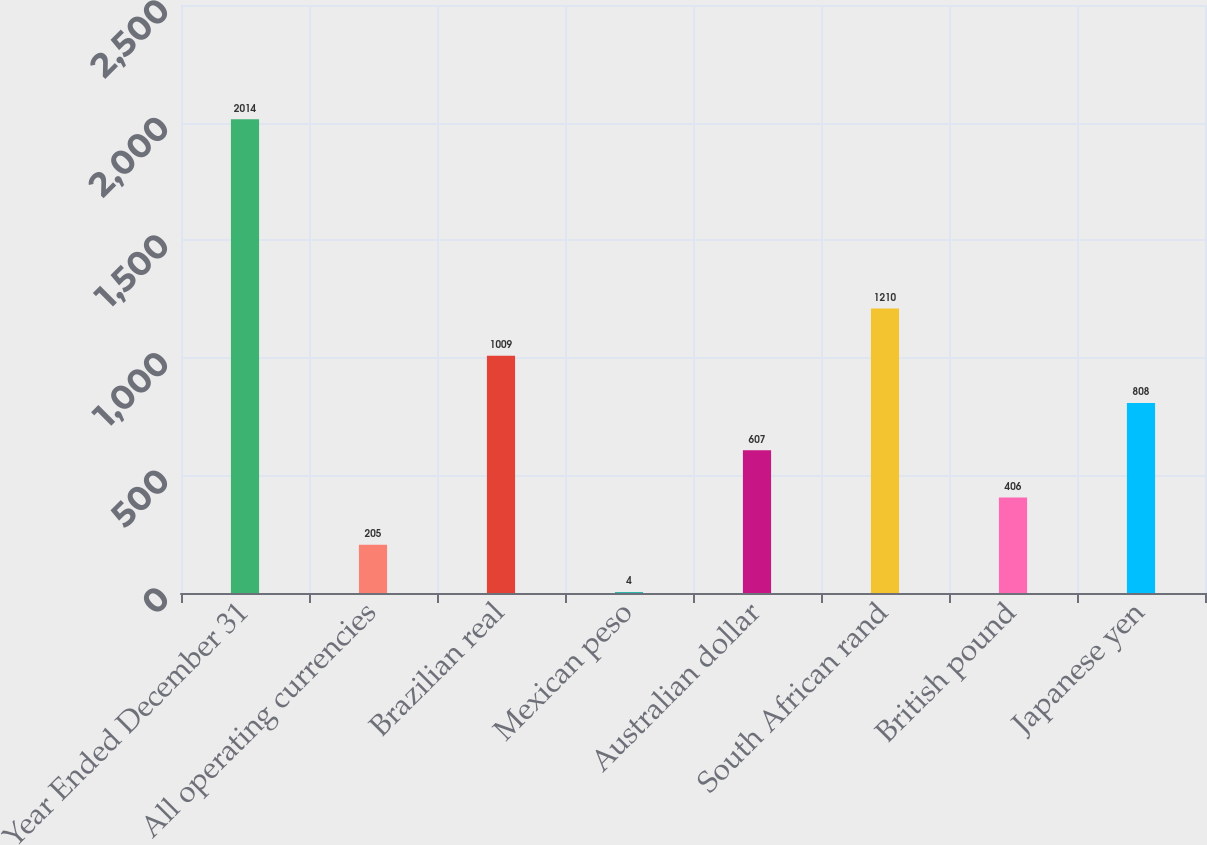Convert chart to OTSL. <chart><loc_0><loc_0><loc_500><loc_500><bar_chart><fcel>Year Ended December 31<fcel>All operating currencies<fcel>Brazilian real<fcel>Mexican peso<fcel>Australian dollar<fcel>South African rand<fcel>British pound<fcel>Japanese yen<nl><fcel>2014<fcel>205<fcel>1009<fcel>4<fcel>607<fcel>1210<fcel>406<fcel>808<nl></chart> 